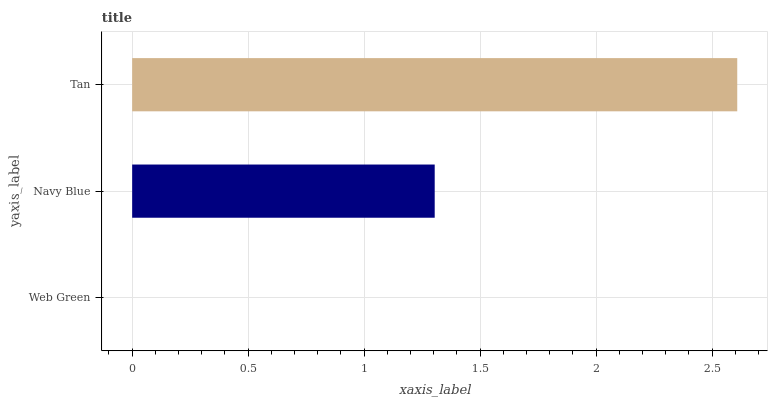Is Web Green the minimum?
Answer yes or no. Yes. Is Tan the maximum?
Answer yes or no. Yes. Is Navy Blue the minimum?
Answer yes or no. No. Is Navy Blue the maximum?
Answer yes or no. No. Is Navy Blue greater than Web Green?
Answer yes or no. Yes. Is Web Green less than Navy Blue?
Answer yes or no. Yes. Is Web Green greater than Navy Blue?
Answer yes or no. No. Is Navy Blue less than Web Green?
Answer yes or no. No. Is Navy Blue the high median?
Answer yes or no. Yes. Is Navy Blue the low median?
Answer yes or no. Yes. Is Tan the high median?
Answer yes or no. No. Is Web Green the low median?
Answer yes or no. No. 